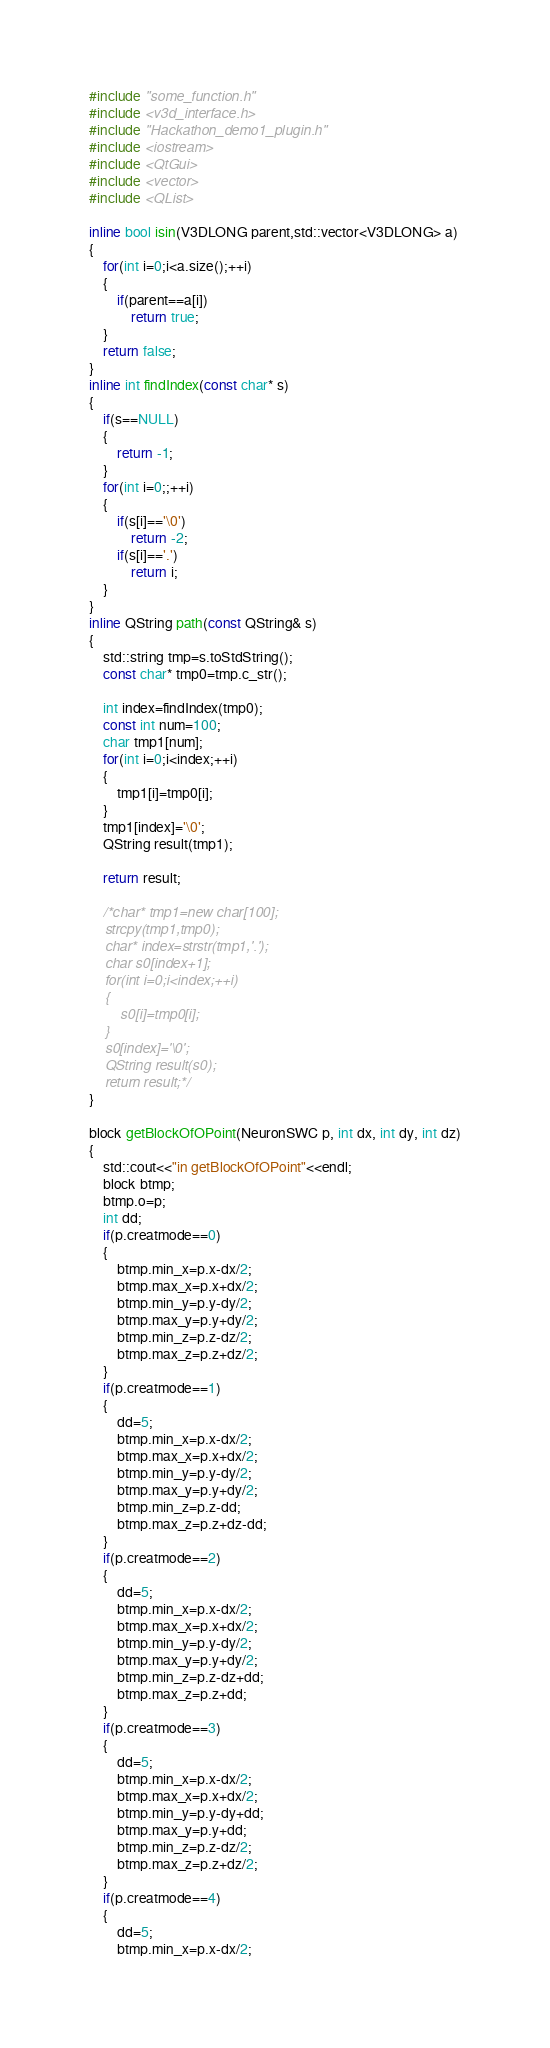Convert code to text. <code><loc_0><loc_0><loc_500><loc_500><_C++_>#include "some_function.h"
#include <v3d_interface.h>
#include "Hackathon_demo1_plugin.h"
#include <iostream>
#include <QtGui>
#include <vector>
#include <QList>

inline bool isin(V3DLONG parent,std::vector<V3DLONG> a)
{
    for(int i=0;i<a.size();++i)
    {
        if(parent==a[i])
            return true;
    }
    return false;
}
inline int findIndex(const char* s)
{
    if(s==NULL)
    {
        return -1;
    }
    for(int i=0;;++i)
    {
        if(s[i]=='\0')
            return -2;
        if(s[i]=='.')
            return i;
    }
}
inline QString path(const QString& s)
{
    std::string tmp=s.toStdString();
    const char* tmp0=tmp.c_str();

    int index=findIndex(tmp0);
    const int num=100;
    char tmp1[num];
    for(int i=0;i<index;++i)
    {
        tmp1[i]=tmp0[i];
    }
    tmp1[index]='\0';
    QString result(tmp1);

    return result;

    /*char* tmp1=new char[100];
    strcpy(tmp1,tmp0);
    char* index=strstr(tmp1,'.');
    char s0[index+1];
    for(int i=0;i<index;++i)
    {
        s0[i]=tmp0[i];
    }
    s0[index]='\0';
    QString result(s0);
    return result;*/
}

block getBlockOfOPoint(NeuronSWC p, int dx, int dy, int dz)
{
    std::cout<<"in getBlockOfOPoint"<<endl;
    block btmp;
    btmp.o=p;
    int dd;
    if(p.creatmode==0)
    {
        btmp.min_x=p.x-dx/2;
        btmp.max_x=p.x+dx/2;
        btmp.min_y=p.y-dy/2;
        btmp.max_y=p.y+dy/2;
        btmp.min_z=p.z-dz/2;
        btmp.max_z=p.z+dz/2;
    }
    if(p.creatmode==1)
    {
        dd=5;
        btmp.min_x=p.x-dx/2;
        btmp.max_x=p.x+dx/2;
        btmp.min_y=p.y-dy/2;
        btmp.max_y=p.y+dy/2;
        btmp.min_z=p.z-dd;
        btmp.max_z=p.z+dz-dd;
    }
    if(p.creatmode==2)
    {
        dd=5;
        btmp.min_x=p.x-dx/2;
        btmp.max_x=p.x+dx/2;
        btmp.min_y=p.y-dy/2;
        btmp.max_y=p.y+dy/2;
        btmp.min_z=p.z-dz+dd;
        btmp.max_z=p.z+dd;
    }
    if(p.creatmode==3)
    {
        dd=5;
        btmp.min_x=p.x-dx/2;
        btmp.max_x=p.x+dx/2;
        btmp.min_y=p.y-dy+dd;
        btmp.max_y=p.y+dd;
        btmp.min_z=p.z-dz/2;
        btmp.max_z=p.z+dz/2;
    }
    if(p.creatmode==4)
    {
        dd=5;
        btmp.min_x=p.x-dx/2;</code> 